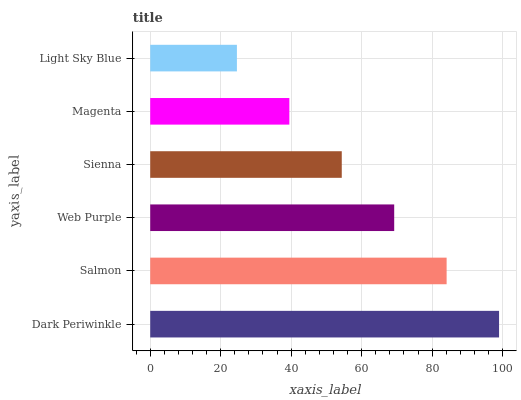Is Light Sky Blue the minimum?
Answer yes or no. Yes. Is Dark Periwinkle the maximum?
Answer yes or no. Yes. Is Salmon the minimum?
Answer yes or no. No. Is Salmon the maximum?
Answer yes or no. No. Is Dark Periwinkle greater than Salmon?
Answer yes or no. Yes. Is Salmon less than Dark Periwinkle?
Answer yes or no. Yes. Is Salmon greater than Dark Periwinkle?
Answer yes or no. No. Is Dark Periwinkle less than Salmon?
Answer yes or no. No. Is Web Purple the high median?
Answer yes or no. Yes. Is Sienna the low median?
Answer yes or no. Yes. Is Salmon the high median?
Answer yes or no. No. Is Salmon the low median?
Answer yes or no. No. 